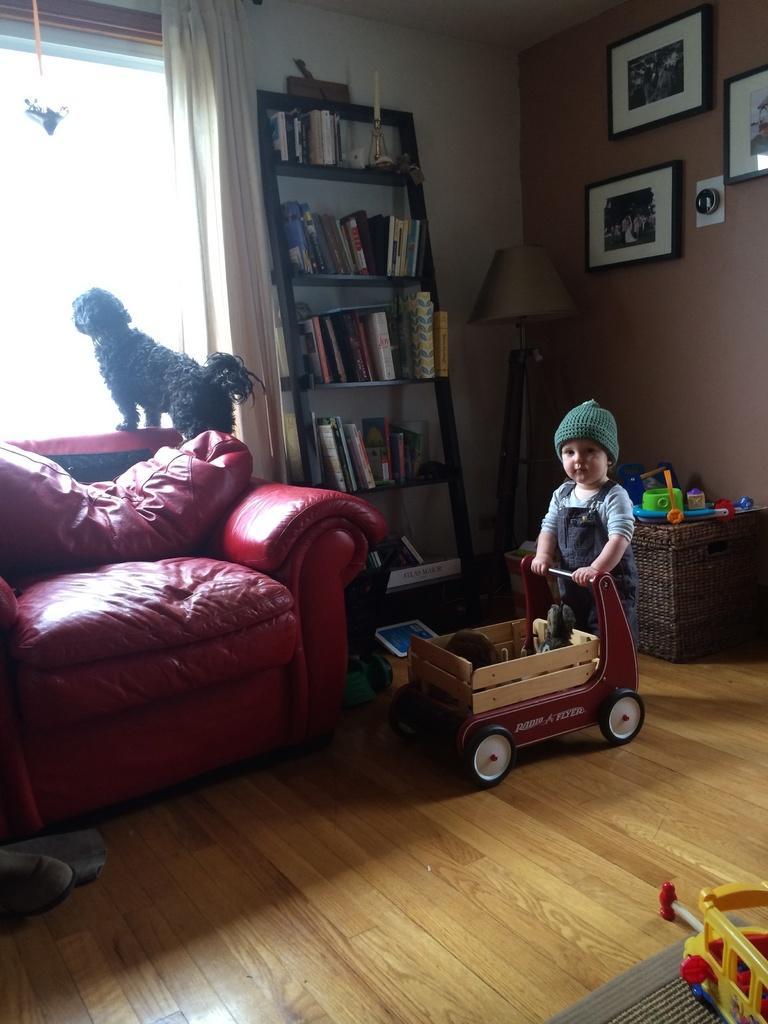Describe this image in one or two sentences. The image is inside the room. In the image on right side there is a kid riding his vehicle and we can also see table,boxes and on wall we can see some photo frames. On right side we can also see a lamp,shelf with some books. On left side there is a dog,couch,window which is closed curtain. 